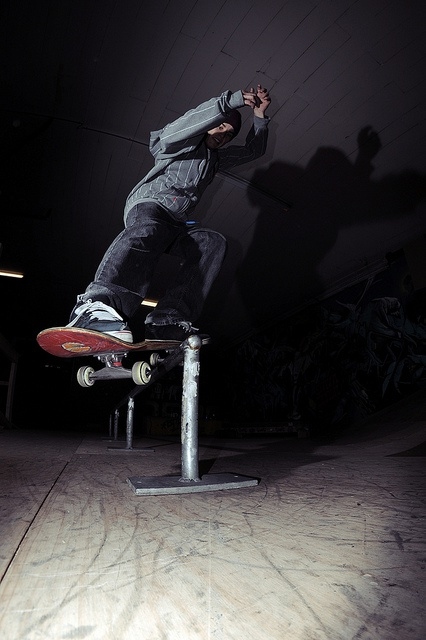Describe the objects in this image and their specific colors. I can see people in black, gray, and darkgray tones and skateboard in black, gray, maroon, and darkgray tones in this image. 